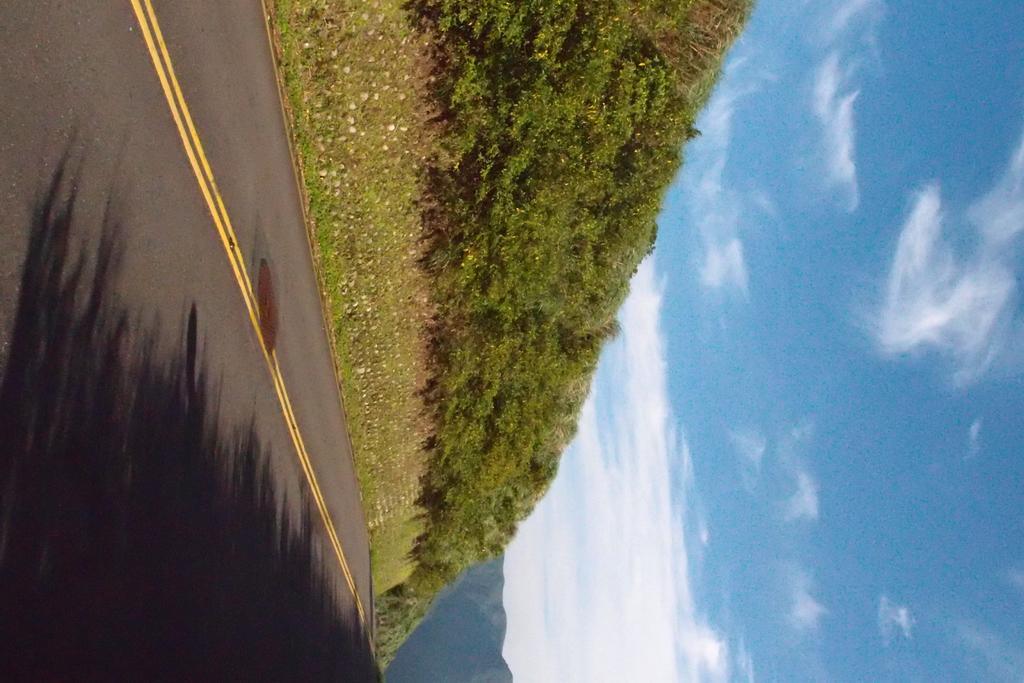In one or two sentences, can you explain what this image depicts? In this image I can see a road and on it I can see two yellow lines and shadows. In the background I can see grass, bushes, the mountain, clouds and the sky. I can also see this is an inverted image. 